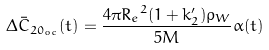<formula> <loc_0><loc_0><loc_500><loc_500>\Delta \bar { C } _ { { 2 0 } _ { o c } } ( t ) = \frac { 4 \pi { R _ { e } } ^ { 2 } ( 1 + k _ { 2 } ^ { \prime } ) \rho _ { W } } { 5 M } \alpha ( t )</formula> 